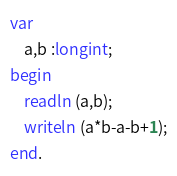<code> <loc_0><loc_0><loc_500><loc_500><_Pascal_>var
    a,b :longint;
begin
    readln (a,b);
	writeln (a*b-a-b+1);
end.</code> 